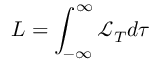Convert formula to latex. <formula><loc_0><loc_0><loc_500><loc_500>L = \int _ { - \infty } ^ { \infty } \mathcal { L } _ { T } d \tau</formula> 